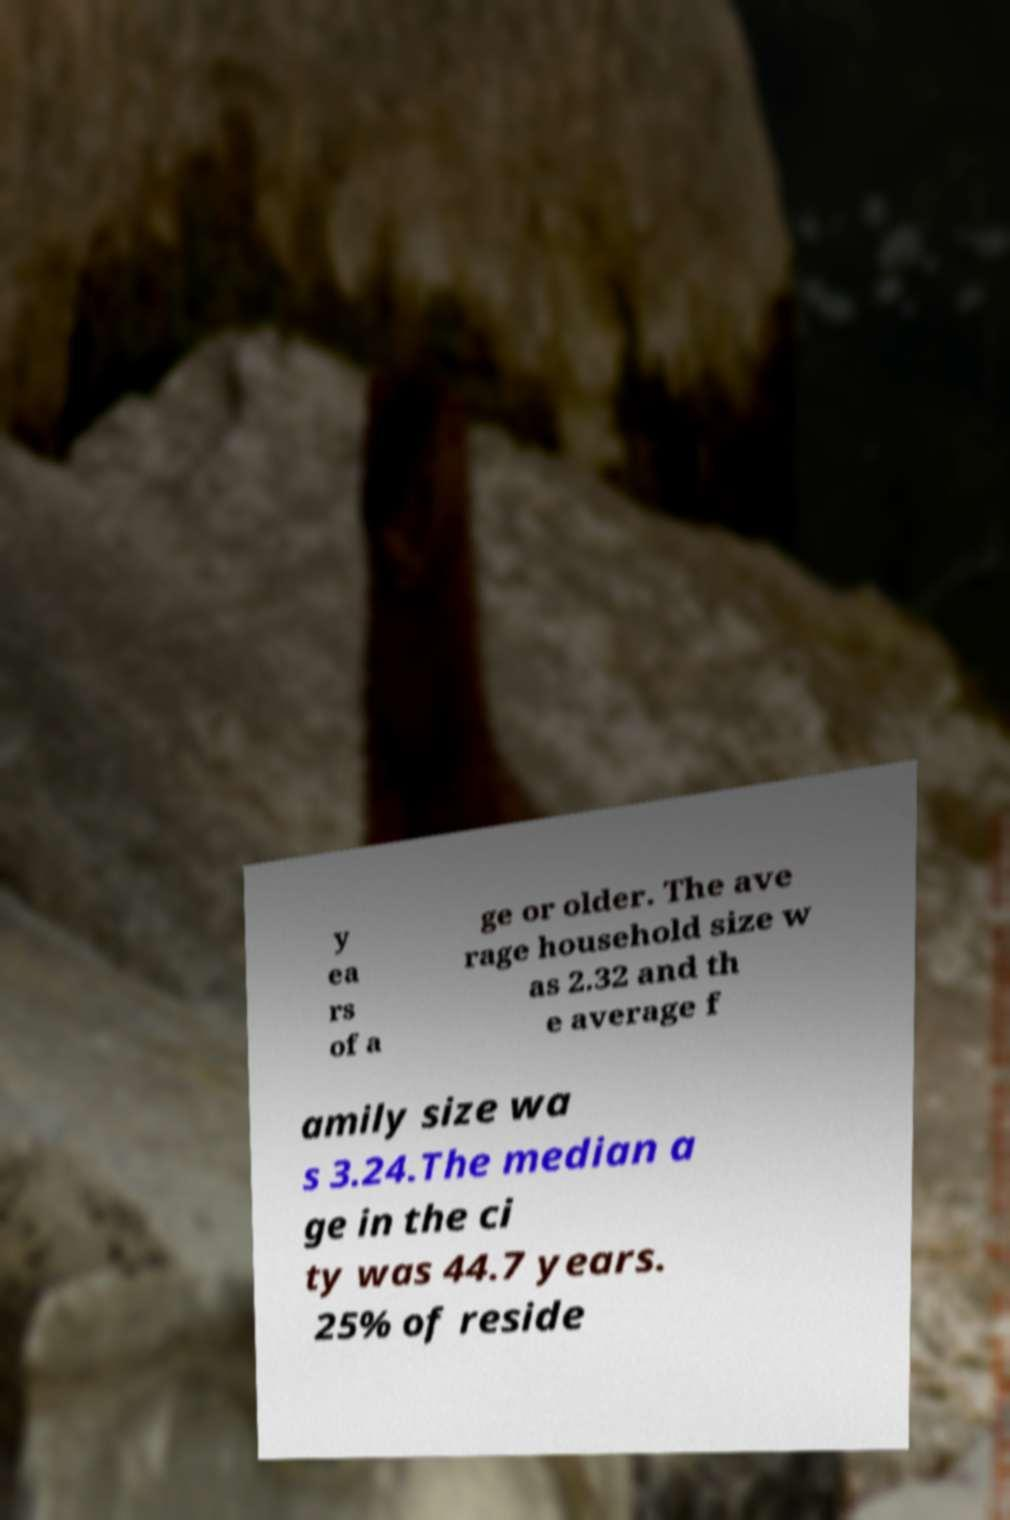What messages or text are displayed in this image? I need them in a readable, typed format. y ea rs of a ge or older. The ave rage household size w as 2.32 and th e average f amily size wa s 3.24.The median a ge in the ci ty was 44.7 years. 25% of reside 